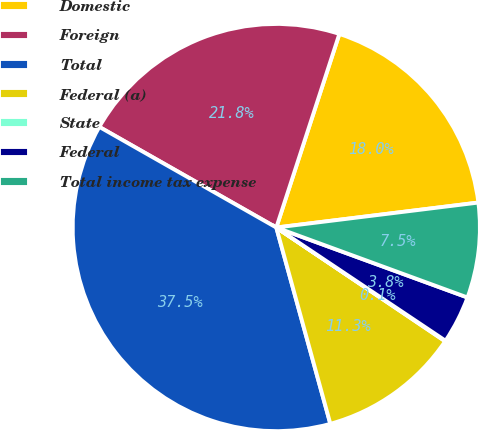Convert chart to OTSL. <chart><loc_0><loc_0><loc_500><loc_500><pie_chart><fcel>Domestic<fcel>Foreign<fcel>Total<fcel>Federal (a)<fcel>State<fcel>Federal<fcel>Total income tax expense<nl><fcel>18.03%<fcel>21.78%<fcel>37.5%<fcel>11.29%<fcel>0.05%<fcel>3.8%<fcel>7.54%<nl></chart> 